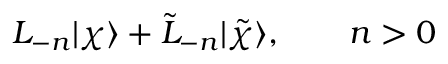<formula> <loc_0><loc_0><loc_500><loc_500>L _ { - n } | \chi \rangle + \tilde { L } _ { - n } | \tilde { \chi } \rangle , \quad n > 0</formula> 